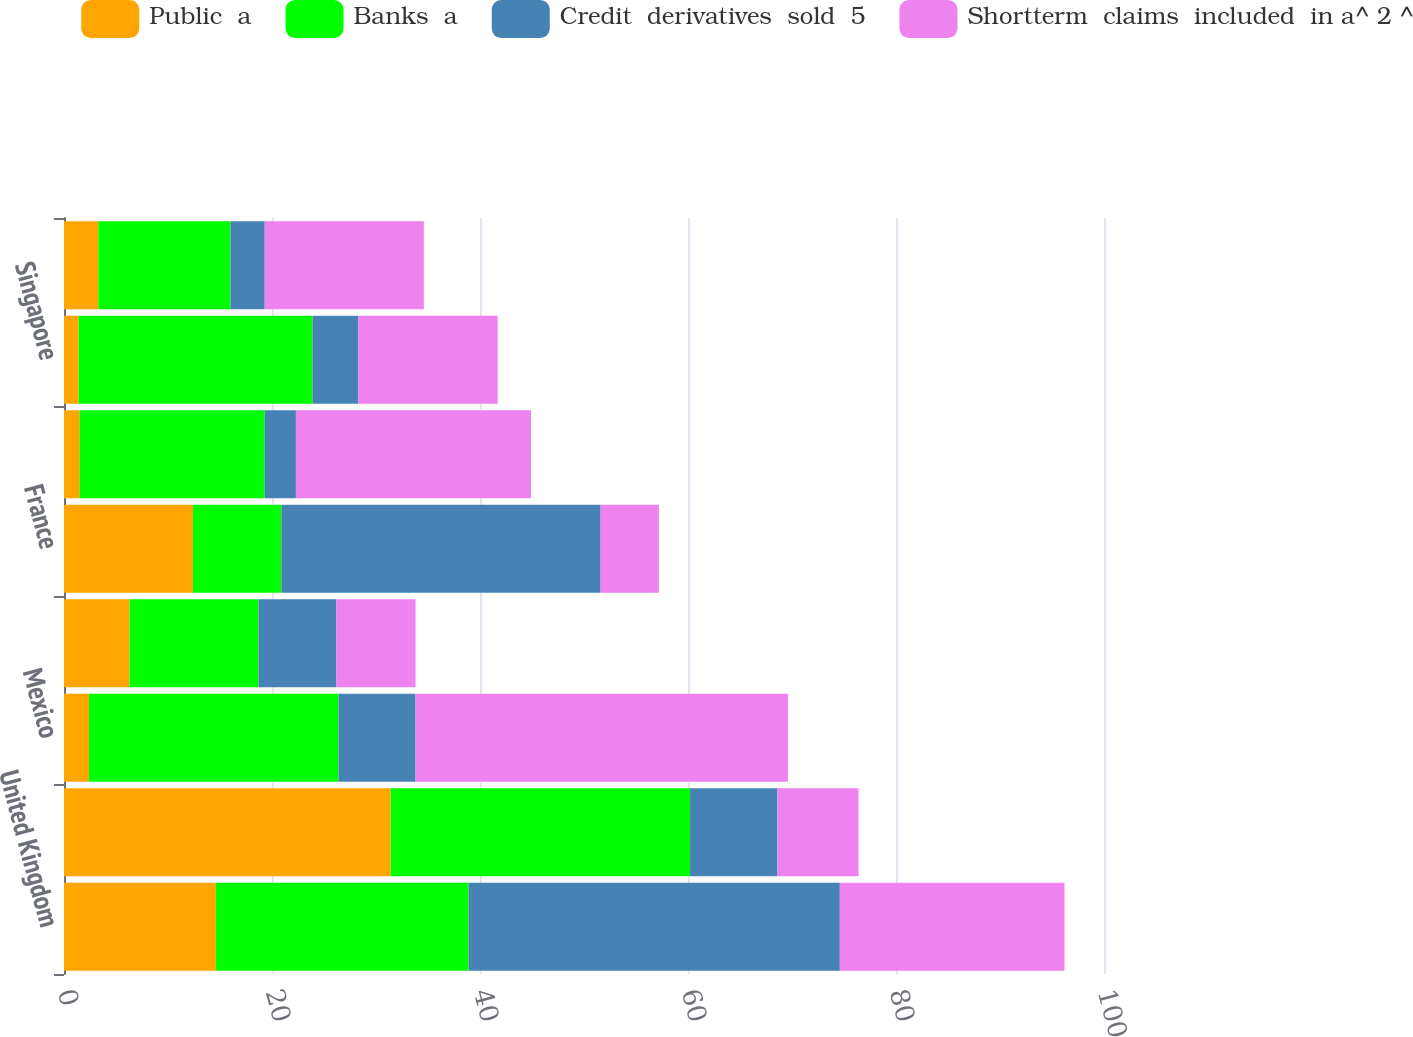<chart> <loc_0><loc_0><loc_500><loc_500><stacked_bar_chart><ecel><fcel>United Kingdom<fcel>Japan<fcel>Mexico<fcel>Germany<fcel>France<fcel>South Korea<fcel>Singapore<fcel>India<nl><fcel>Public  a<fcel>14.6<fcel>31.4<fcel>2.4<fcel>6.3<fcel>12.4<fcel>1.5<fcel>1.4<fcel>3.3<nl><fcel>Banks  a<fcel>24.3<fcel>28.8<fcel>24<fcel>12.4<fcel>8.5<fcel>17.8<fcel>22.5<fcel>12.7<nl><fcel>Credit  derivatives  sold  5<fcel>35.7<fcel>8.4<fcel>7.4<fcel>7.5<fcel>30.7<fcel>3<fcel>4.4<fcel>3.3<nl><fcel>Shortterm  claims  included  in a^ 2 ^<fcel>21.6<fcel>7.8<fcel>35.8<fcel>7.6<fcel>5.6<fcel>22.6<fcel>13.4<fcel>15.3<nl></chart> 